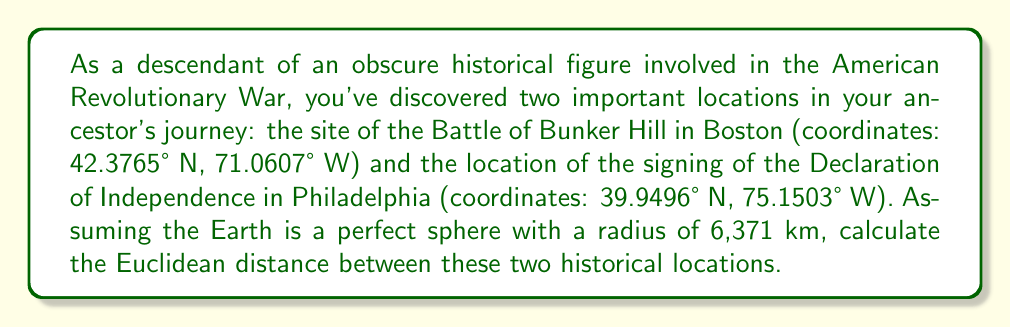Can you solve this math problem? To solve this problem, we'll use the Euclidean distance formula in three-dimensional space, considering the Earth as a sphere. We'll follow these steps:

1. Convert the latitude and longitude coordinates to radians.
2. Calculate the Cartesian coordinates (x, y, z) for each location on the sphere.
3. Apply the Euclidean distance formula between the two points.

Step 1: Convert coordinates to radians
Boston: $(42.3765°N, 71.0607°W)$
$\text{lat}_1 = 42.3765° \cdot \frac{\pi}{180} = 0.7396 \text{ rad}$
$\text{lon}_1 = -71.0607° \cdot \frac{\pi}{180} = -1.2403 \text{ rad}$

Philadelphia: $(39.9496°N, 75.1503°W)$
$\text{lat}_2 = 39.9496° \cdot \frac{\pi}{180} = 0.6972 \text{ rad}$
$\text{lon}_2 = -75.1503° \cdot \frac{\pi}{180} = -1.3117 \text{ rad}$

Step 2: Calculate Cartesian coordinates
For a point $(lat, lon)$ on a sphere with radius $R$, the Cartesian coordinates are:
$$x = R \cos(lat) \cos(lon)$$
$$y = R \cos(lat) \sin(lon)$$
$$z = R \sin(lat)$$

Boston $(x_1, y_1, z_1)$:
$$x_1 = 6371 \cdot \cos(0.7396) \cos(-1.2403) = 4469.8489$$
$$y_1 = 6371 \cdot \cos(0.7396) \sin(-1.2403) = -3348.0619$$
$$z_1 = 6371 \cdot \sin(0.7396) = 4287.5111$$

Philadelphia $(x_2, y_2, z_2)$:
$$x_2 = 6371 \cdot \cos(0.6972) \cos(-1.3117) = 4154.6813$$
$$y_2 = 6371 \cdot \cos(0.6972) \sin(-1.3117) = -3657.3676$$
$$z_2 = 6371 \cdot \sin(0.6972) = 4078.3033$$

Step 3: Apply the Euclidean distance formula
The Euclidean distance $d$ between two points $(x_1, y_1, z_1)$ and $(x_2, y_2, z_2)$ is:
$$d = \sqrt{(x_2 - x_1)^2 + (y_2 - y_1)^2 + (z_2 - z_1)^2}$$

Substituting our values:
$$d = \sqrt{(4154.6813 - 4469.8489)^2 + (-3657.3676 - (-3348.0619))^2 + (4078.3033 - 4287.5111)^2}$$
$$d = \sqrt{(-315.1676)^2 + (-309.3057)^2 + (-209.2078)^2}$$
$$d = \sqrt{99330.7054 + 95669.8178 + 43767.9031}$$
$$d = \sqrt{238768.4263}$$
$$d = 488.6392 \text{ km}$$

Therefore, the Euclidean distance between the Battle of Bunker Hill site and the Independence Hall in Philadelphia is approximately 488.64 km.
Answer: $488.64 \text{ km}$ 